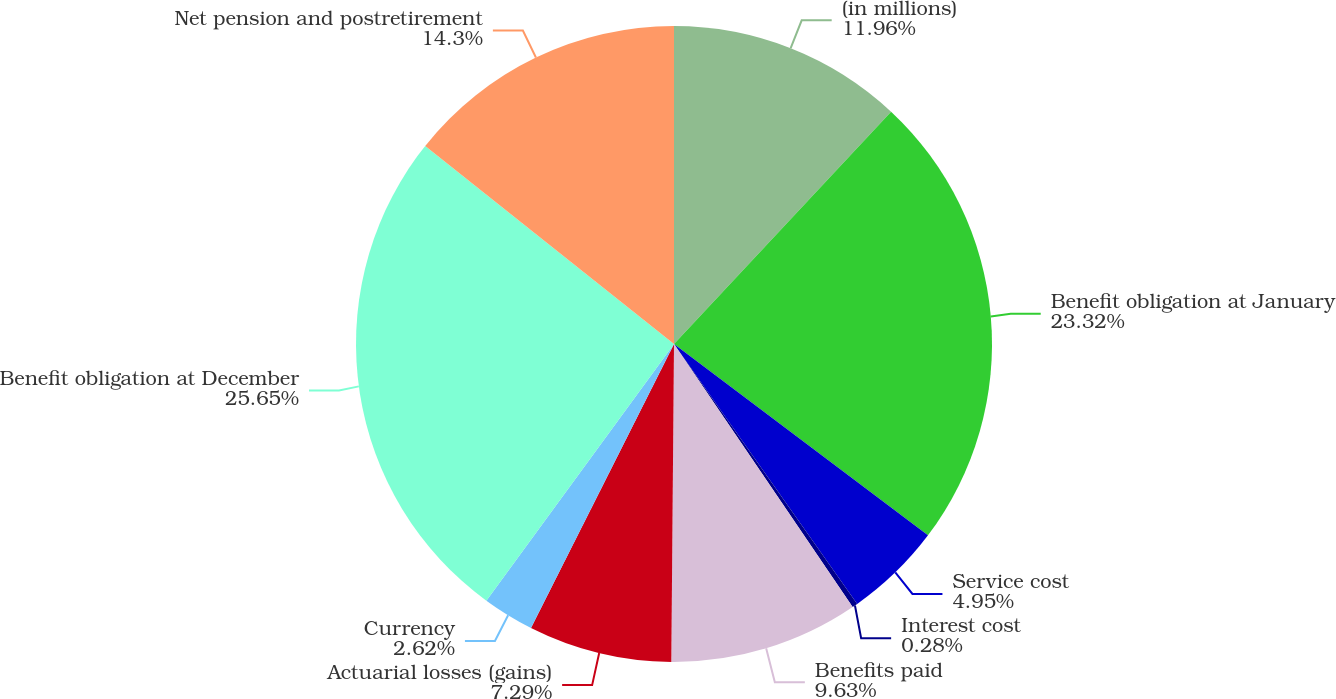<chart> <loc_0><loc_0><loc_500><loc_500><pie_chart><fcel>(in millions)<fcel>Benefit obligation at January<fcel>Service cost<fcel>Interest cost<fcel>Benefits paid<fcel>Actuarial losses (gains)<fcel>Currency<fcel>Benefit obligation at December<fcel>Net pension and postretirement<nl><fcel>11.96%<fcel>23.32%<fcel>4.95%<fcel>0.28%<fcel>9.63%<fcel>7.29%<fcel>2.62%<fcel>25.66%<fcel>14.3%<nl></chart> 